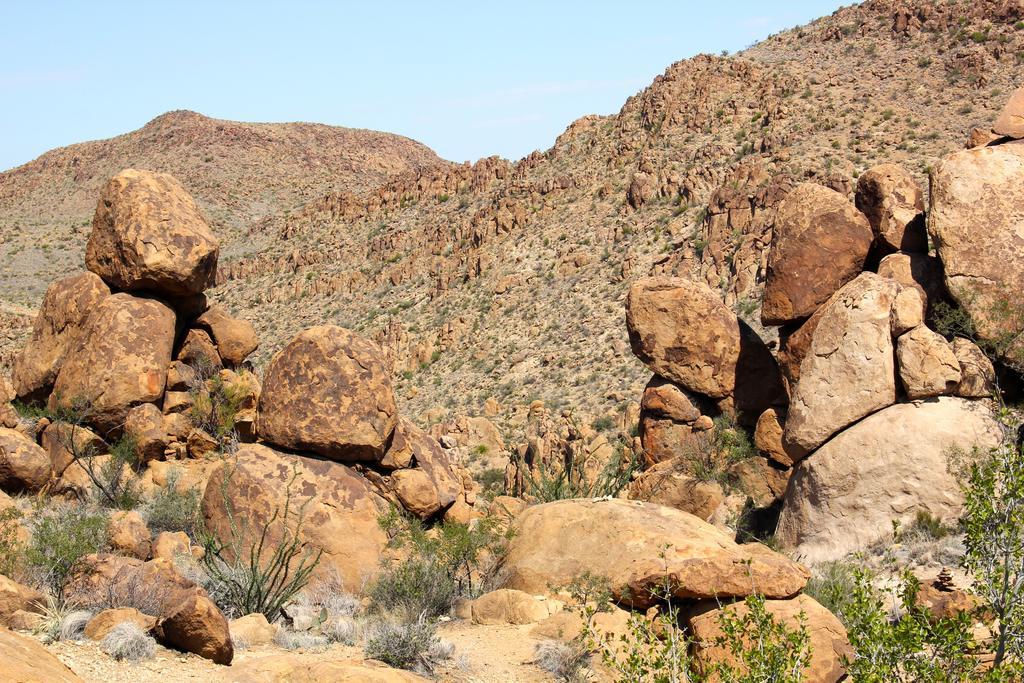How would you summarize this image in a sentence or two? In this image there are plants, rocks, hills,sky. 